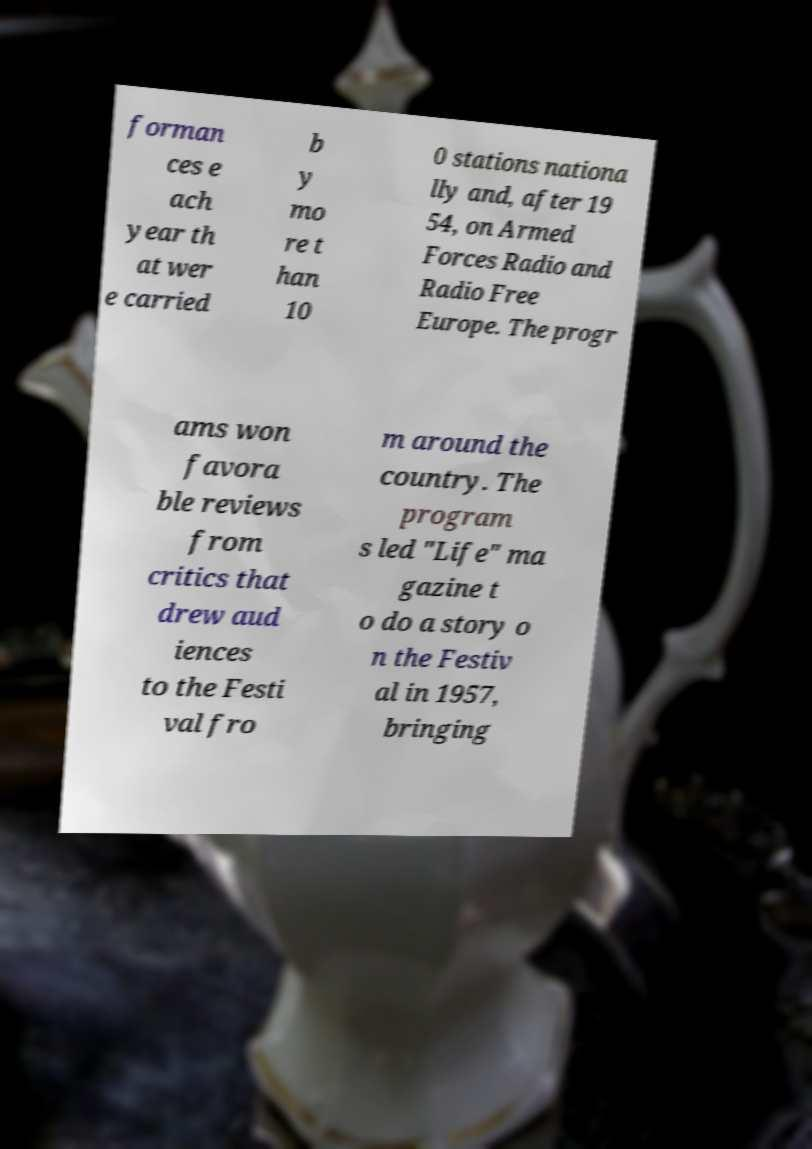Can you accurately transcribe the text from the provided image for me? forman ces e ach year th at wer e carried b y mo re t han 10 0 stations nationa lly and, after 19 54, on Armed Forces Radio and Radio Free Europe. The progr ams won favora ble reviews from critics that drew aud iences to the Festi val fro m around the country. The program s led "Life" ma gazine t o do a story o n the Festiv al in 1957, bringing 